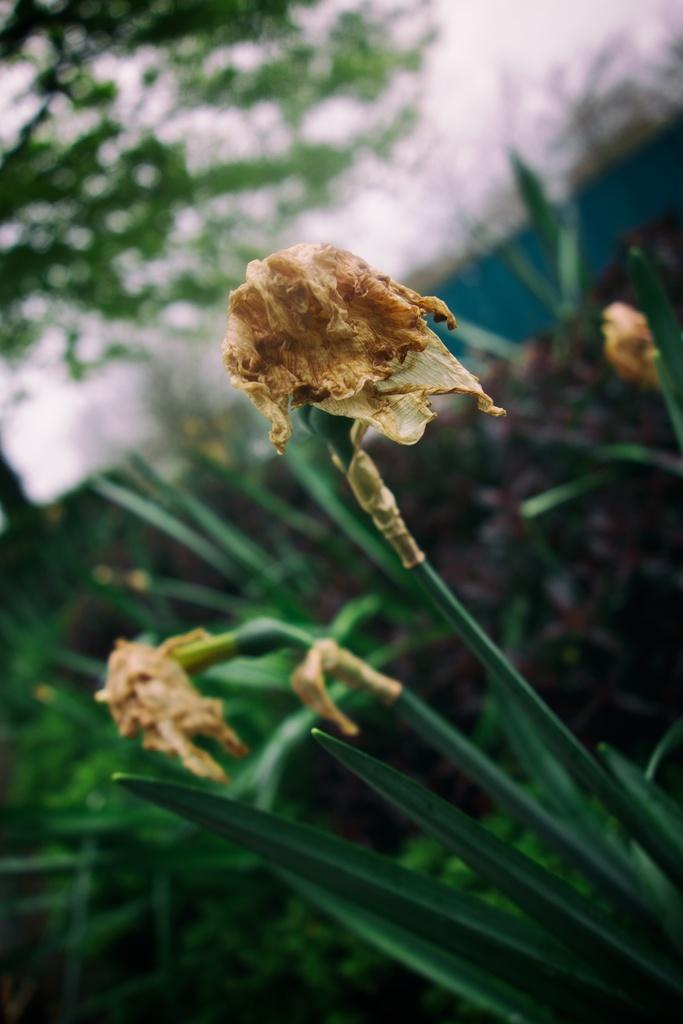What type of living organisms can be seen in the image? Plants can be seen in the image. What is the condition of the flowers in the image? The flowers in the image are dry. Can you describe the background of the image? The background of the image is blurred. What type of meat is being played on the musical instrument in the image? There is no meat or musical instrument present in the image. 